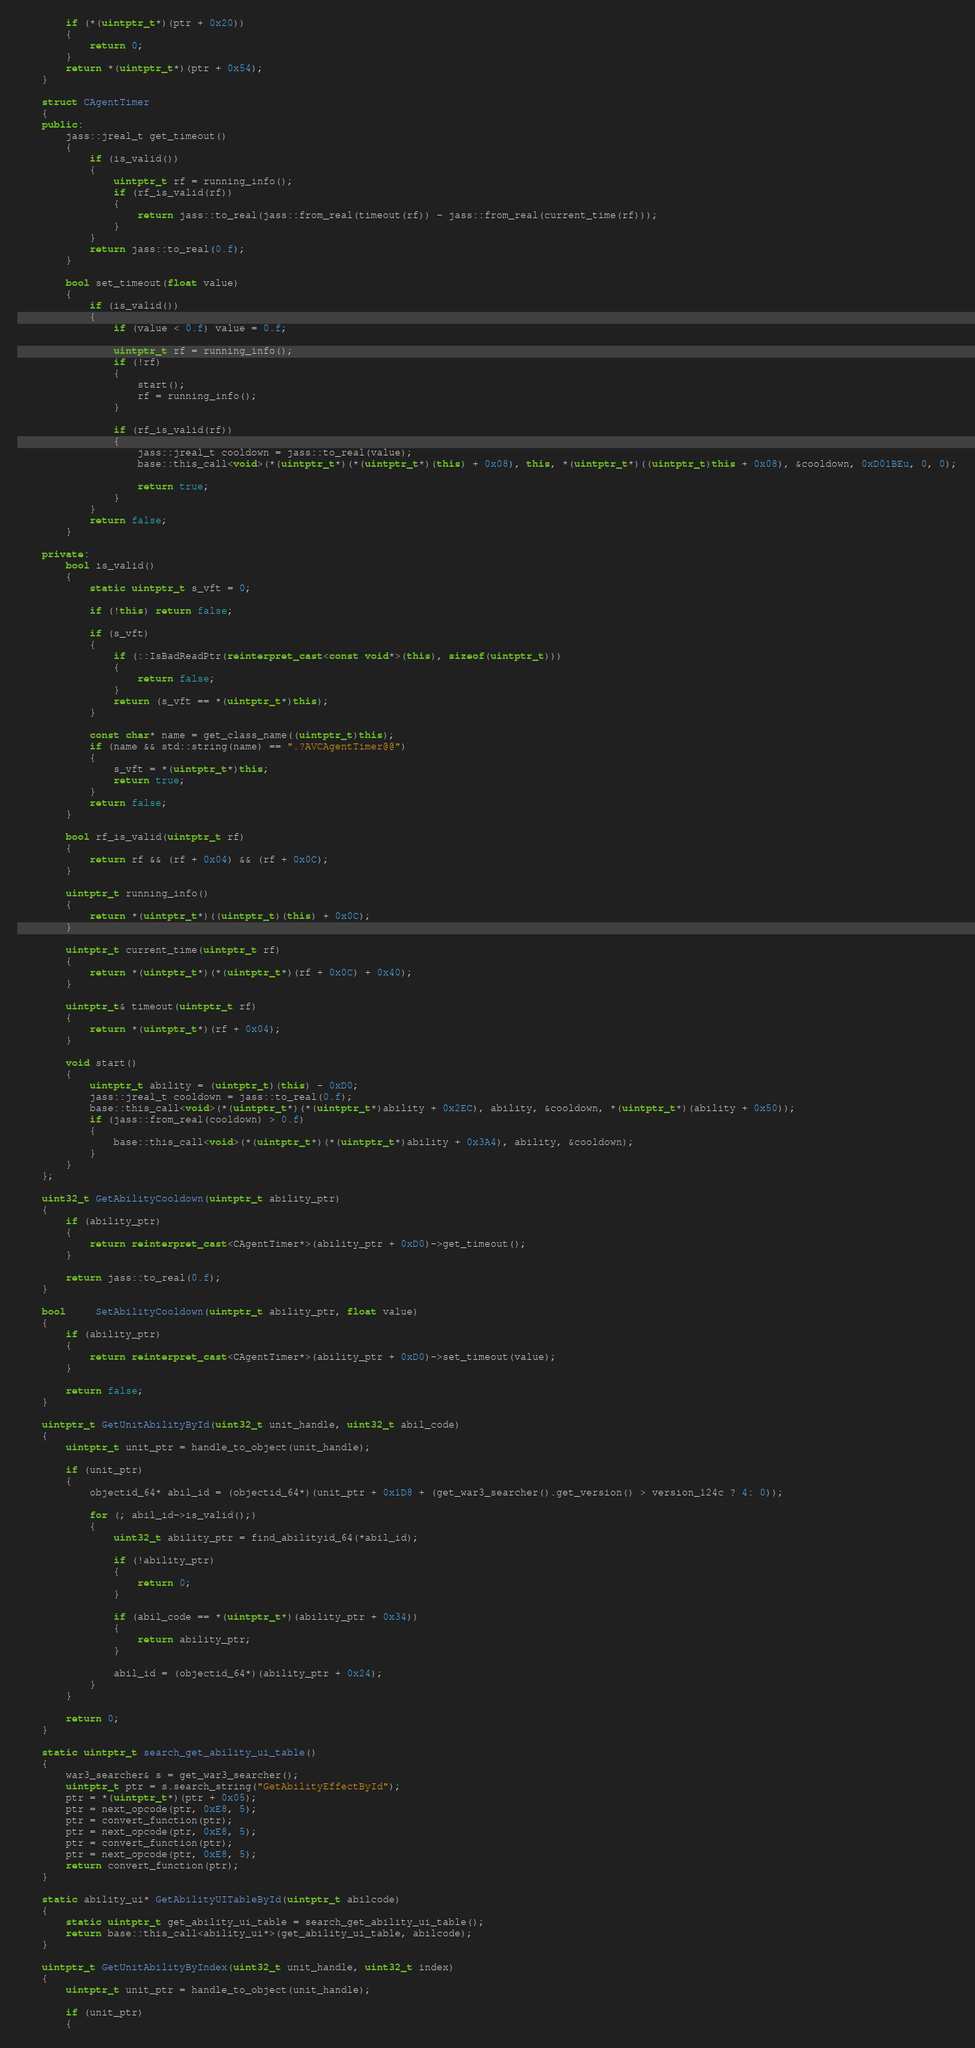Convert code to text. <code><loc_0><loc_0><loc_500><loc_500><_C++_>		if (*(uintptr_t*)(ptr + 0x20))
		{
			return 0;
		}
		return *(uintptr_t*)(ptr + 0x54);
	}

	struct CAgentTimer
	{
	public:
		jass::jreal_t get_timeout()
		{
			if (is_valid())
			{
				uintptr_t rf = running_info();
				if (rf_is_valid(rf))
				{
					return jass::to_real(jass::from_real(timeout(rf)) - jass::from_real(current_time(rf)));
				}
			}
			return jass::to_real(0.f);
		}

		bool set_timeout(float value)
		{
			if (is_valid())
			{
				if (value < 0.f) value = 0.f;

				uintptr_t rf = running_info();
				if (!rf)
				{
					start();
					rf = running_info();
				}

				if (rf_is_valid(rf))
				{
					jass::jreal_t cooldown = jass::to_real(value);
					base::this_call<void>(*(uintptr_t*)(*(uintptr_t*)(this) + 0x08), this, *(uintptr_t*)((uintptr_t)this + 0x08), &cooldown, 0xD01BEu, 0, 0);

					return true;
				}
			}
			return false;
		}

	private:
		bool is_valid()
		{
			static uintptr_t s_vft = 0;

			if (!this) return false;

			if (s_vft)
			{
				if (::IsBadReadPtr(reinterpret_cast<const void*>(this), sizeof(uintptr_t)))
				{
					return false;
				}
				return (s_vft == *(uintptr_t*)this);
			}

			const char* name = get_class_name((uintptr_t)this);
			if (name && std::string(name) == ".?AVCAgentTimer@@")
			{
				s_vft = *(uintptr_t*)this;
				return true;
			}
			return false;
		}

		bool rf_is_valid(uintptr_t rf)
		{ 
			return rf && (rf + 0x04) && (rf + 0x0C);
		}

		uintptr_t running_info()
		{
			return *(uintptr_t*)((uintptr_t)(this) + 0x0C);
		}

		uintptr_t current_time(uintptr_t rf) 
		{  
			return *(uintptr_t*)(*(uintptr_t*)(rf + 0x0C) + 0x40);
		}

		uintptr_t& timeout(uintptr_t rf) 
		{  
			return *(uintptr_t*)(rf + 0x04);
		}

		void start()
		{
			uintptr_t ability = (uintptr_t)(this) - 0xD0;
			jass::jreal_t cooldown = jass::to_real(0.f);
            base::this_call<void>(*(uintptr_t*)(*(uintptr_t*)ability + 0x2EC), ability, &cooldown, *(uintptr_t*)(ability + 0x50));
			if (jass::from_real(cooldown) > 0.f)
			{
                base::this_call<void>(*(uintptr_t*)(*(uintptr_t*)ability + 0x3A4), ability, &cooldown);
			}
		}
	};

	uint32_t GetAbilityCooldown(uintptr_t ability_ptr)
	{
		if (ability_ptr)
		{
			return reinterpret_cast<CAgentTimer*>(ability_ptr + 0xD0)->get_timeout();
		}

		return jass::to_real(0.f);
	}

	bool     SetAbilityCooldown(uintptr_t ability_ptr, float value)
	{	
		if (ability_ptr)
		{
			return reinterpret_cast<CAgentTimer*>(ability_ptr + 0xD0)->set_timeout(value);
		}

		return false;
	}

	uintptr_t GetUnitAbilityById(uint32_t unit_handle, uint32_t abil_code)
	{
		uintptr_t unit_ptr = handle_to_object(unit_handle);

		if (unit_ptr)
		{
			objectid_64* abil_id = (objectid_64*)(unit_ptr + 0x1D8 + (get_war3_searcher().get_version() > version_124c ? 4: 0));

			for (; abil_id->is_valid();)
			{
				uint32_t ability_ptr = find_abilityid_64(*abil_id);

				if (!ability_ptr)
				{
					return 0;
				}

				if (abil_code == *(uintptr_t*)(ability_ptr + 0x34))
				{
					return ability_ptr;
				}

				abil_id = (objectid_64*)(ability_ptr + 0x24);
			}
		}

		return 0;
	}

	static uintptr_t search_get_ability_ui_table()
	{
		war3_searcher& s = get_war3_searcher();
		uintptr_t ptr = s.search_string("GetAbilityEffectById");
		ptr = *(uintptr_t*)(ptr + 0x05);
		ptr = next_opcode(ptr, 0xE8, 5);
		ptr = convert_function(ptr);
		ptr = next_opcode(ptr, 0xE8, 5);
		ptr = convert_function(ptr);
		ptr = next_opcode(ptr, 0xE8, 5);
		return convert_function(ptr);
	}

	static ability_ui* GetAbilityUITableById(uintptr_t abilcode)
	{
		static uintptr_t get_ability_ui_table = search_get_ability_ui_table();
		return base::this_call<ability_ui*>(get_ability_ui_table, abilcode);
	}

	uintptr_t GetUnitAbilityByIndex(uint32_t unit_handle, uint32_t index)
	{
		uintptr_t unit_ptr = handle_to_object(unit_handle);

		if (unit_ptr)
		{</code> 